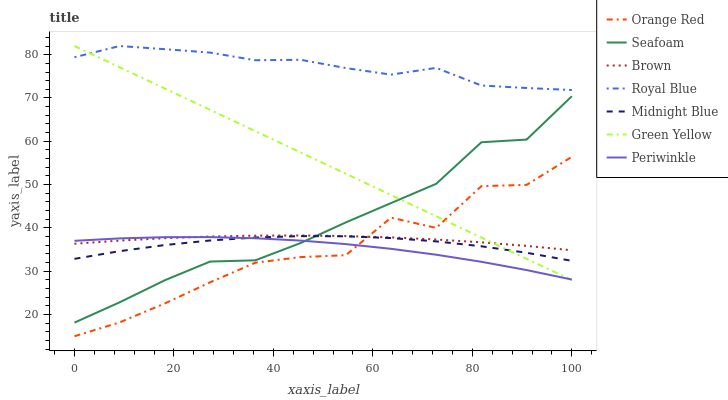Does Orange Red have the minimum area under the curve?
Answer yes or no. Yes. Does Royal Blue have the maximum area under the curve?
Answer yes or no. Yes. Does Midnight Blue have the minimum area under the curve?
Answer yes or no. No. Does Midnight Blue have the maximum area under the curve?
Answer yes or no. No. Is Green Yellow the smoothest?
Answer yes or no. Yes. Is Orange Red the roughest?
Answer yes or no. Yes. Is Midnight Blue the smoothest?
Answer yes or no. No. Is Midnight Blue the roughest?
Answer yes or no. No. Does Orange Red have the lowest value?
Answer yes or no. Yes. Does Midnight Blue have the lowest value?
Answer yes or no. No. Does Green Yellow have the highest value?
Answer yes or no. Yes. Does Midnight Blue have the highest value?
Answer yes or no. No. Is Periwinkle less than Royal Blue?
Answer yes or no. Yes. Is Royal Blue greater than Midnight Blue?
Answer yes or no. Yes. Does Orange Red intersect Midnight Blue?
Answer yes or no. Yes. Is Orange Red less than Midnight Blue?
Answer yes or no. No. Is Orange Red greater than Midnight Blue?
Answer yes or no. No. Does Periwinkle intersect Royal Blue?
Answer yes or no. No. 